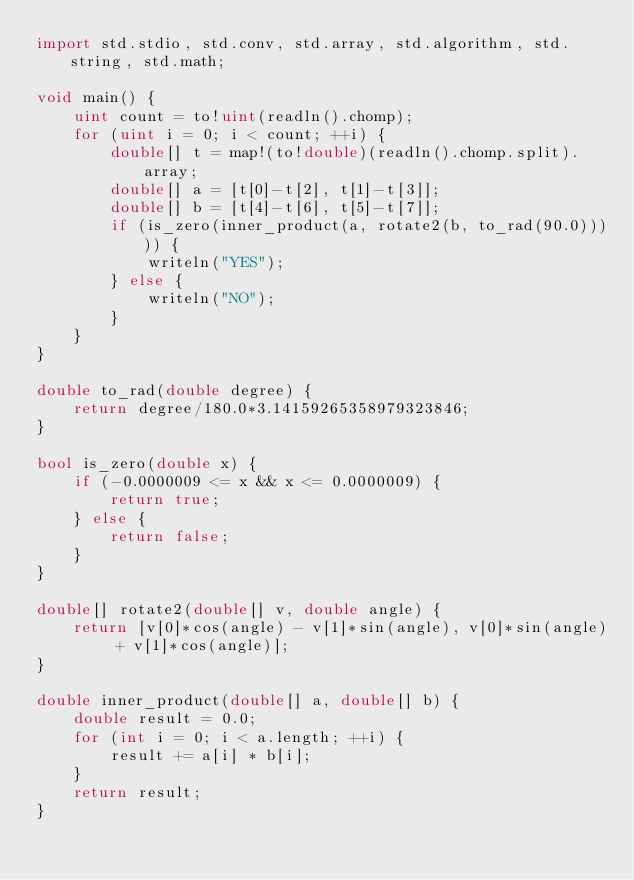<code> <loc_0><loc_0><loc_500><loc_500><_D_>import std.stdio, std.conv, std.array, std.algorithm, std.string, std.math;

void main() {
    uint count = to!uint(readln().chomp);
    for (uint i = 0; i < count; ++i) {
        double[] t = map!(to!double)(readln().chomp.split).array;
        double[] a = [t[0]-t[2], t[1]-t[3]];
        double[] b = [t[4]-t[6], t[5]-t[7]];
        if (is_zero(inner_product(a, rotate2(b, to_rad(90.0))))) {
            writeln("YES");
        } else {
            writeln("NO");   
        }
    }
}

double to_rad(double degree) {
    return degree/180.0*3.14159265358979323846;   
}

bool is_zero(double x) {
    if (-0.0000009 <= x && x <= 0.0000009) {
        return true;
    } else {
        return false;
    }
}

double[] rotate2(double[] v, double angle) {
    return [v[0]*cos(angle) - v[1]*sin(angle), v[0]*sin(angle) + v[1]*cos(angle)];
}

double inner_product(double[] a, double[] b) {
    double result = 0.0;
    for (int i = 0; i < a.length; ++i) {
        result += a[i] * b[i];
    }
    return result;
}</code> 